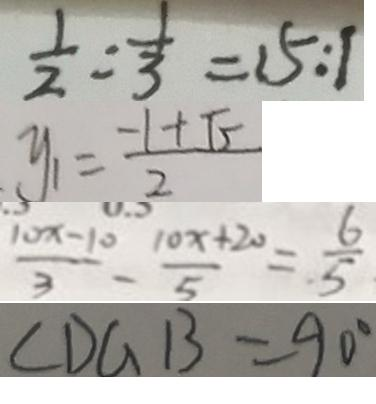<formula> <loc_0><loc_0><loc_500><loc_500>\frac { 1 } { 2 } : \frac { 1 } { 3 } = 1 5 : 1 
 y _ { 1 } = \frac { - 1 + \sqrt { 5 } } { 2 } 
 \frac { 1 0 x - 1 0 } { 3 } - \frac { 1 0 x + 2 0 } { 5 } = \frac { 6 } { 5 } 
 \angle D G B = 9 0 ^ { \circ }</formula> 